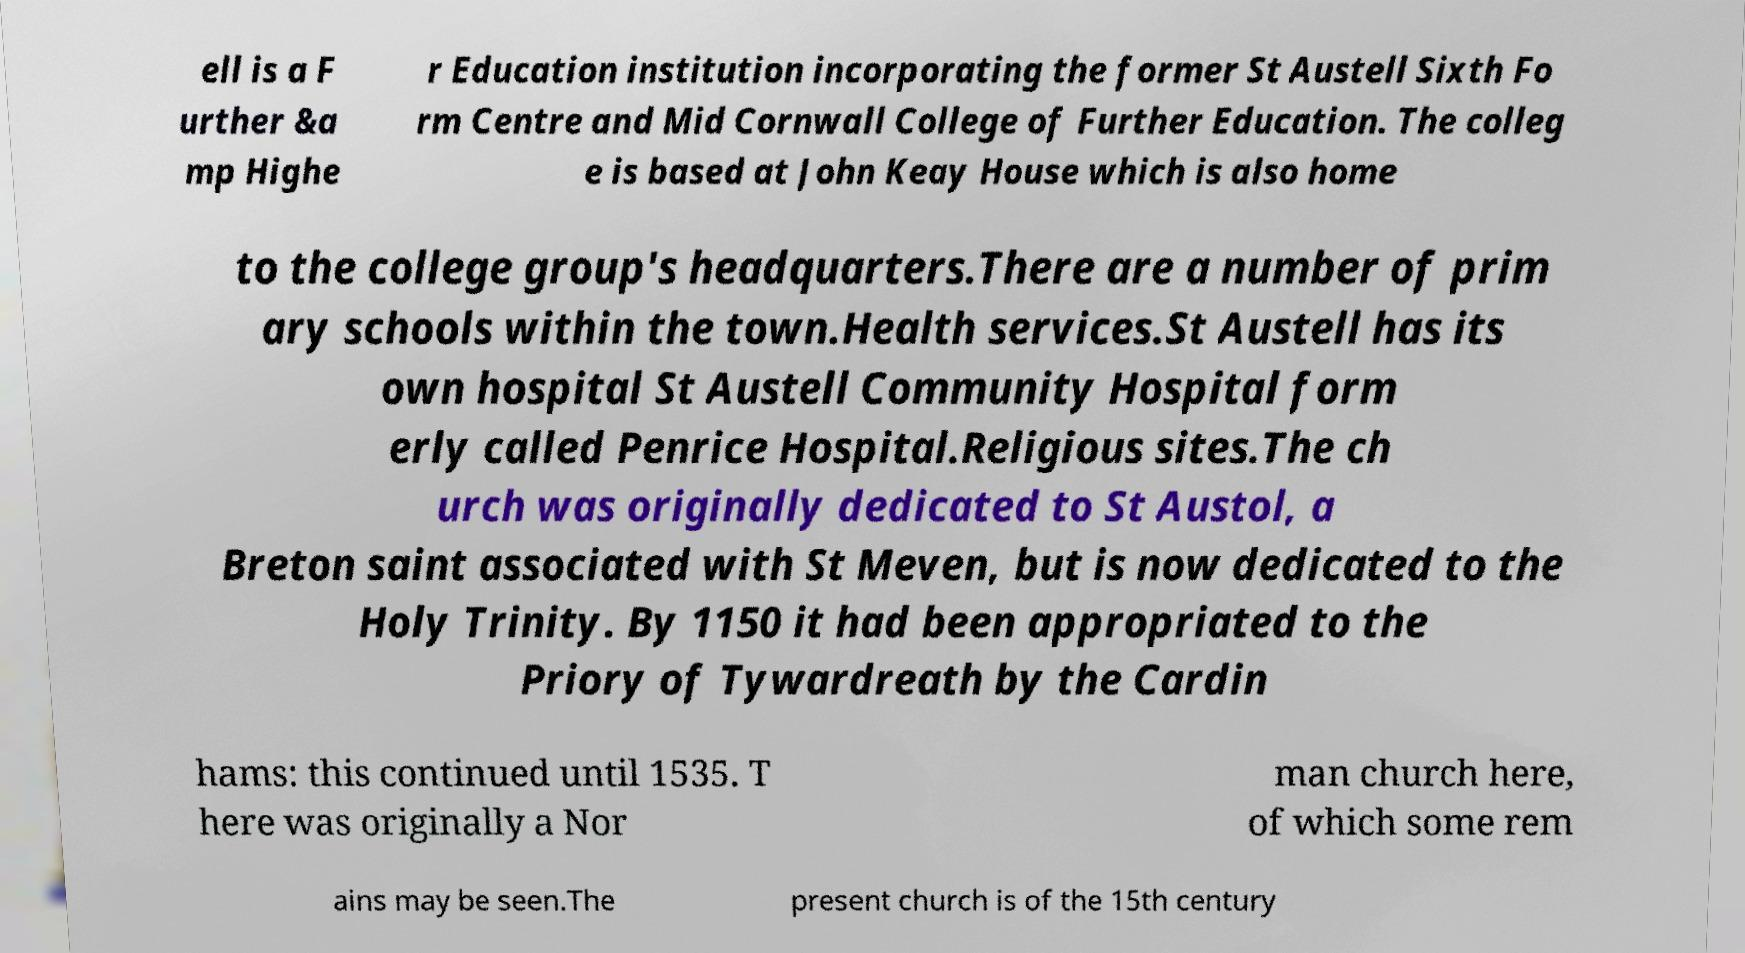What messages or text are displayed in this image? I need them in a readable, typed format. ell is a F urther &a mp Highe r Education institution incorporating the former St Austell Sixth Fo rm Centre and Mid Cornwall College of Further Education. The colleg e is based at John Keay House which is also home to the college group's headquarters.There are a number of prim ary schools within the town.Health services.St Austell has its own hospital St Austell Community Hospital form erly called Penrice Hospital.Religious sites.The ch urch was originally dedicated to St Austol, a Breton saint associated with St Meven, but is now dedicated to the Holy Trinity. By 1150 it had been appropriated to the Priory of Tywardreath by the Cardin hams: this continued until 1535. T here was originally a Nor man church here, of which some rem ains may be seen.The present church is of the 15th century 